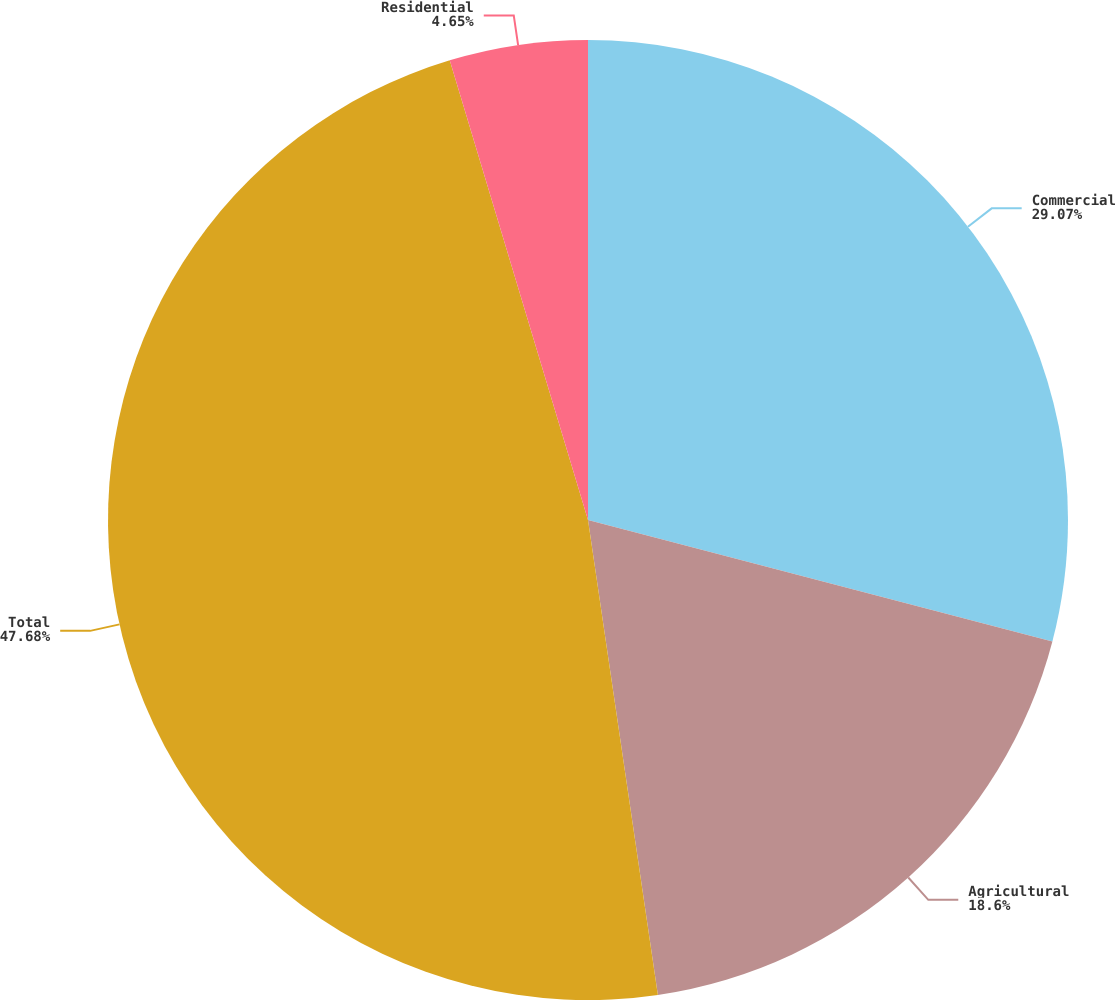Convert chart. <chart><loc_0><loc_0><loc_500><loc_500><pie_chart><fcel>Commercial<fcel>Agricultural<fcel>Total<fcel>Residential<nl><fcel>29.07%<fcel>18.6%<fcel>47.67%<fcel>4.65%<nl></chart> 